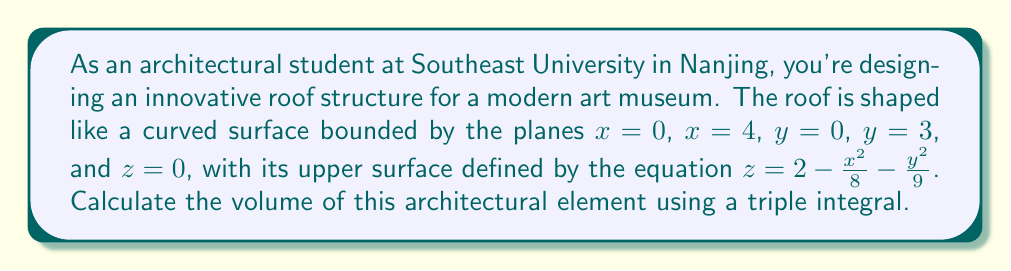Show me your answer to this math problem. To calculate the volume of this irregularly shaped architectural element, we need to set up and evaluate a triple integral. Let's approach this step-by-step:

1) The volume is bounded by:
   $0 \leq x \leq 4$
   $0 \leq y \leq 3$
   $0 \leq z \leq 2 - \frac{x^2}{8} - \frac{y^2}{9}$

2) We'll set up the triple integral:

   $$V = \int_0^4 \int_0^3 \int_0^{2 - \frac{x^2}{8} - \frac{y^2}{9}} 1\, dz\, dy\, dx$$

3) Let's evaluate the innermost integral first:

   $$\int_0^{2 - \frac{x^2}{8} - \frac{y^2}{9}} 1\, dz = 2 - \frac{x^2}{8} - \frac{y^2}{9}$$

4) Now our integral becomes:

   $$V = \int_0^4 \int_0^3 (2 - \frac{x^2}{8} - \frac{y^2}{9})\, dy\, dx$$

5) Let's evaluate the $y$ integral:

   $$\int_0^3 (2 - \frac{x^2}{8} - \frac{y^2}{9})\, dy = 2y - \frac{x^2y}{8} - \frac{y^3}{27}\bigg|_0^3$$
   $$= (6 - \frac{3x^2}{8} - 1) = 5 - \frac{3x^2}{8}$$

6) Our integral is now:

   $$V = \int_0^4 (5 - \frac{3x^2}{8})\, dx$$

7) Finally, let's evaluate this integral:

   $$V = 5x - \frac{x^3}{8}\bigg|_0^4$$
   $$= (20 - 8) - (0 - 0) = 12$$

Therefore, the volume of the roof structure is 12 cubic units.
Answer: 12 cubic units 